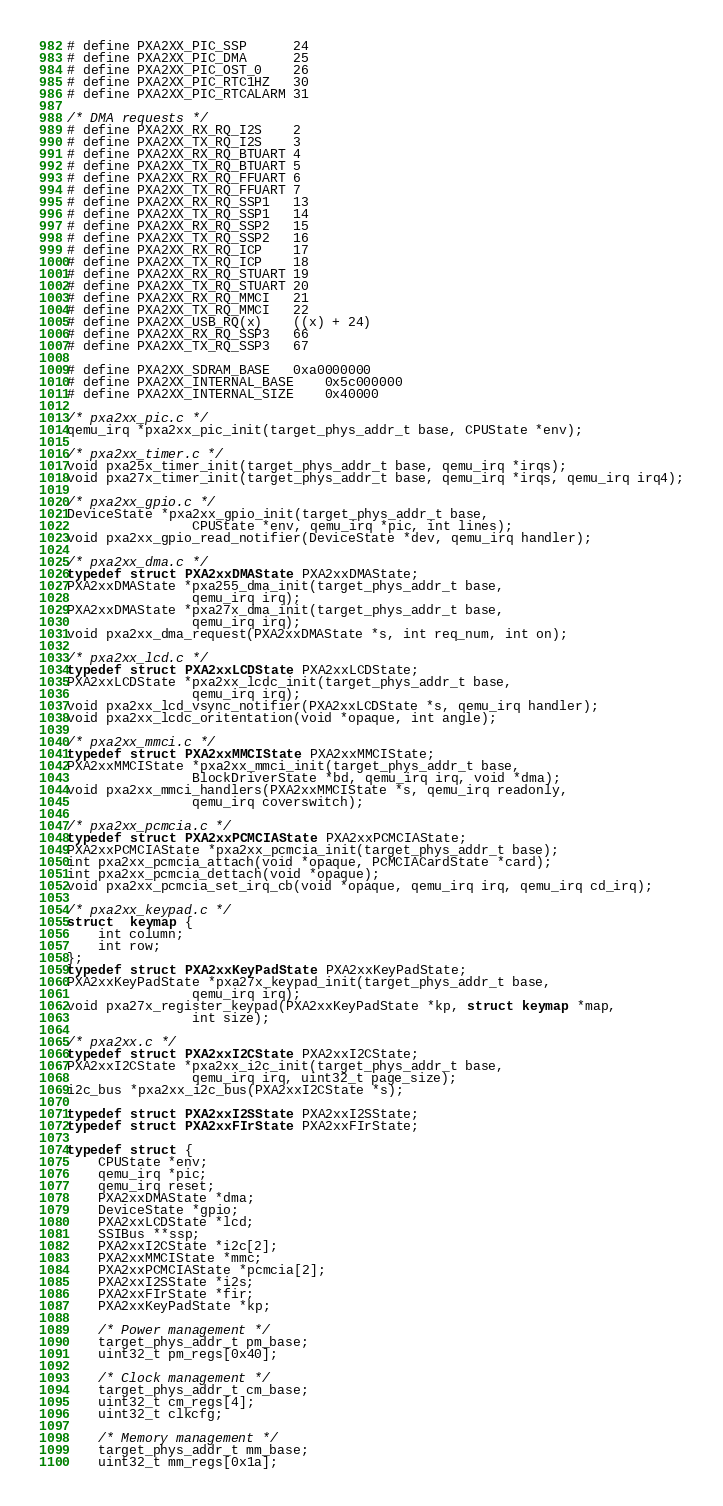<code> <loc_0><loc_0><loc_500><loc_500><_C_># define PXA2XX_PIC_SSP		24
# define PXA2XX_PIC_DMA		25
# define PXA2XX_PIC_OST_0	26
# define PXA2XX_PIC_RTC1HZ	30
# define PXA2XX_PIC_RTCALARM	31

/* DMA requests */
# define PXA2XX_RX_RQ_I2S	2
# define PXA2XX_TX_RQ_I2S	3
# define PXA2XX_RX_RQ_BTUART	4
# define PXA2XX_TX_RQ_BTUART	5
# define PXA2XX_RX_RQ_FFUART	6
# define PXA2XX_TX_RQ_FFUART	7
# define PXA2XX_RX_RQ_SSP1	13
# define PXA2XX_TX_RQ_SSP1	14
# define PXA2XX_RX_RQ_SSP2	15
# define PXA2XX_TX_RQ_SSP2	16
# define PXA2XX_RX_RQ_ICP	17
# define PXA2XX_TX_RQ_ICP	18
# define PXA2XX_RX_RQ_STUART	19
# define PXA2XX_TX_RQ_STUART	20
# define PXA2XX_RX_RQ_MMCI	21
# define PXA2XX_TX_RQ_MMCI	22
# define PXA2XX_USB_RQ(x)	((x) + 24)
# define PXA2XX_RX_RQ_SSP3	66
# define PXA2XX_TX_RQ_SSP3	67

# define PXA2XX_SDRAM_BASE	0xa0000000
# define PXA2XX_INTERNAL_BASE	0x5c000000
# define PXA2XX_INTERNAL_SIZE	0x40000

/* pxa2xx_pic.c */
qemu_irq *pxa2xx_pic_init(target_phys_addr_t base, CPUState *env);

/* pxa2xx_timer.c */
void pxa25x_timer_init(target_phys_addr_t base, qemu_irq *irqs);
void pxa27x_timer_init(target_phys_addr_t base, qemu_irq *irqs, qemu_irq irq4);

/* pxa2xx_gpio.c */
DeviceState *pxa2xx_gpio_init(target_phys_addr_t base,
                CPUState *env, qemu_irq *pic, int lines);
void pxa2xx_gpio_read_notifier(DeviceState *dev, qemu_irq handler);

/* pxa2xx_dma.c */
typedef struct PXA2xxDMAState PXA2xxDMAState;
PXA2xxDMAState *pxa255_dma_init(target_phys_addr_t base,
                qemu_irq irq);
PXA2xxDMAState *pxa27x_dma_init(target_phys_addr_t base,
                qemu_irq irq);
void pxa2xx_dma_request(PXA2xxDMAState *s, int req_num, int on);

/* pxa2xx_lcd.c */
typedef struct PXA2xxLCDState PXA2xxLCDState;
PXA2xxLCDState *pxa2xx_lcdc_init(target_phys_addr_t base,
                qemu_irq irq);
void pxa2xx_lcd_vsync_notifier(PXA2xxLCDState *s, qemu_irq handler);
void pxa2xx_lcdc_oritentation(void *opaque, int angle);

/* pxa2xx_mmci.c */
typedef struct PXA2xxMMCIState PXA2xxMMCIState;
PXA2xxMMCIState *pxa2xx_mmci_init(target_phys_addr_t base,
                BlockDriverState *bd, qemu_irq irq, void *dma);
void pxa2xx_mmci_handlers(PXA2xxMMCIState *s, qemu_irq readonly,
                qemu_irq coverswitch);

/* pxa2xx_pcmcia.c */
typedef struct PXA2xxPCMCIAState PXA2xxPCMCIAState;
PXA2xxPCMCIAState *pxa2xx_pcmcia_init(target_phys_addr_t base);
int pxa2xx_pcmcia_attach(void *opaque, PCMCIACardState *card);
int pxa2xx_pcmcia_dettach(void *opaque);
void pxa2xx_pcmcia_set_irq_cb(void *opaque, qemu_irq irq, qemu_irq cd_irq);

/* pxa2xx_keypad.c */
struct  keymap {
    int column;
    int row;
};
typedef struct PXA2xxKeyPadState PXA2xxKeyPadState;
PXA2xxKeyPadState *pxa27x_keypad_init(target_phys_addr_t base,
                qemu_irq irq);
void pxa27x_register_keypad(PXA2xxKeyPadState *kp, struct keymap *map,
                int size);

/* pxa2xx.c */
typedef struct PXA2xxI2CState PXA2xxI2CState;
PXA2xxI2CState *pxa2xx_i2c_init(target_phys_addr_t base,
                qemu_irq irq, uint32_t page_size);
i2c_bus *pxa2xx_i2c_bus(PXA2xxI2CState *s);

typedef struct PXA2xxI2SState PXA2xxI2SState;
typedef struct PXA2xxFIrState PXA2xxFIrState;

typedef struct {
    CPUState *env;
    qemu_irq *pic;
    qemu_irq reset;
    PXA2xxDMAState *dma;
    DeviceState *gpio;
    PXA2xxLCDState *lcd;
    SSIBus **ssp;
    PXA2xxI2CState *i2c[2];
    PXA2xxMMCIState *mmc;
    PXA2xxPCMCIAState *pcmcia[2];
    PXA2xxI2SState *i2s;
    PXA2xxFIrState *fir;
    PXA2xxKeyPadState *kp;

    /* Power management */
    target_phys_addr_t pm_base;
    uint32_t pm_regs[0x40];

    /* Clock management */
    target_phys_addr_t cm_base;
    uint32_t cm_regs[4];
    uint32_t clkcfg;

    /* Memory management */
    target_phys_addr_t mm_base;
    uint32_t mm_regs[0x1a];
</code> 